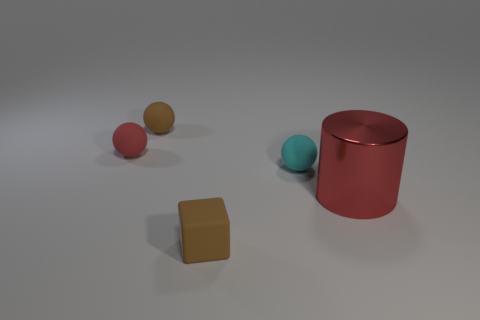Add 2 tiny matte objects. How many objects exist? 7 Subtract all cubes. How many objects are left? 4 Add 1 blue metal things. How many blue metal things exist? 1 Subtract 0 yellow spheres. How many objects are left? 5 Subtract all red objects. Subtract all big metal objects. How many objects are left? 2 Add 2 cyan rubber things. How many cyan rubber things are left? 3 